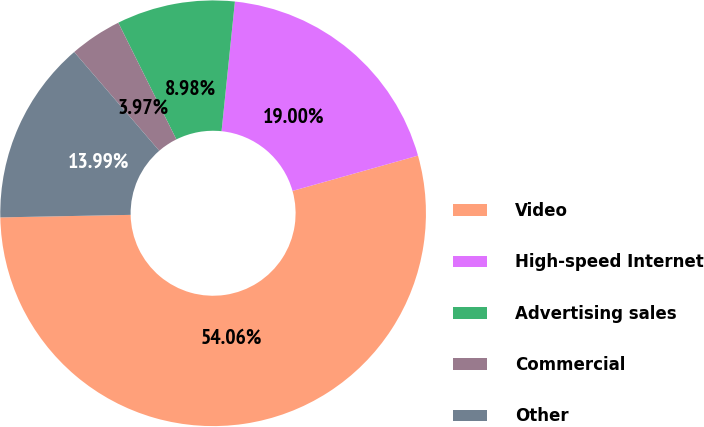Convert chart to OTSL. <chart><loc_0><loc_0><loc_500><loc_500><pie_chart><fcel>Video<fcel>High-speed Internet<fcel>Advertising sales<fcel>Commercial<fcel>Other<nl><fcel>54.05%<fcel>19.0%<fcel>8.98%<fcel>3.97%<fcel>13.99%<nl></chart> 